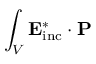Convert formula to latex. <formula><loc_0><loc_0><loc_500><loc_500>\int _ { V } E _ { i n c } ^ { * } \cdot P</formula> 